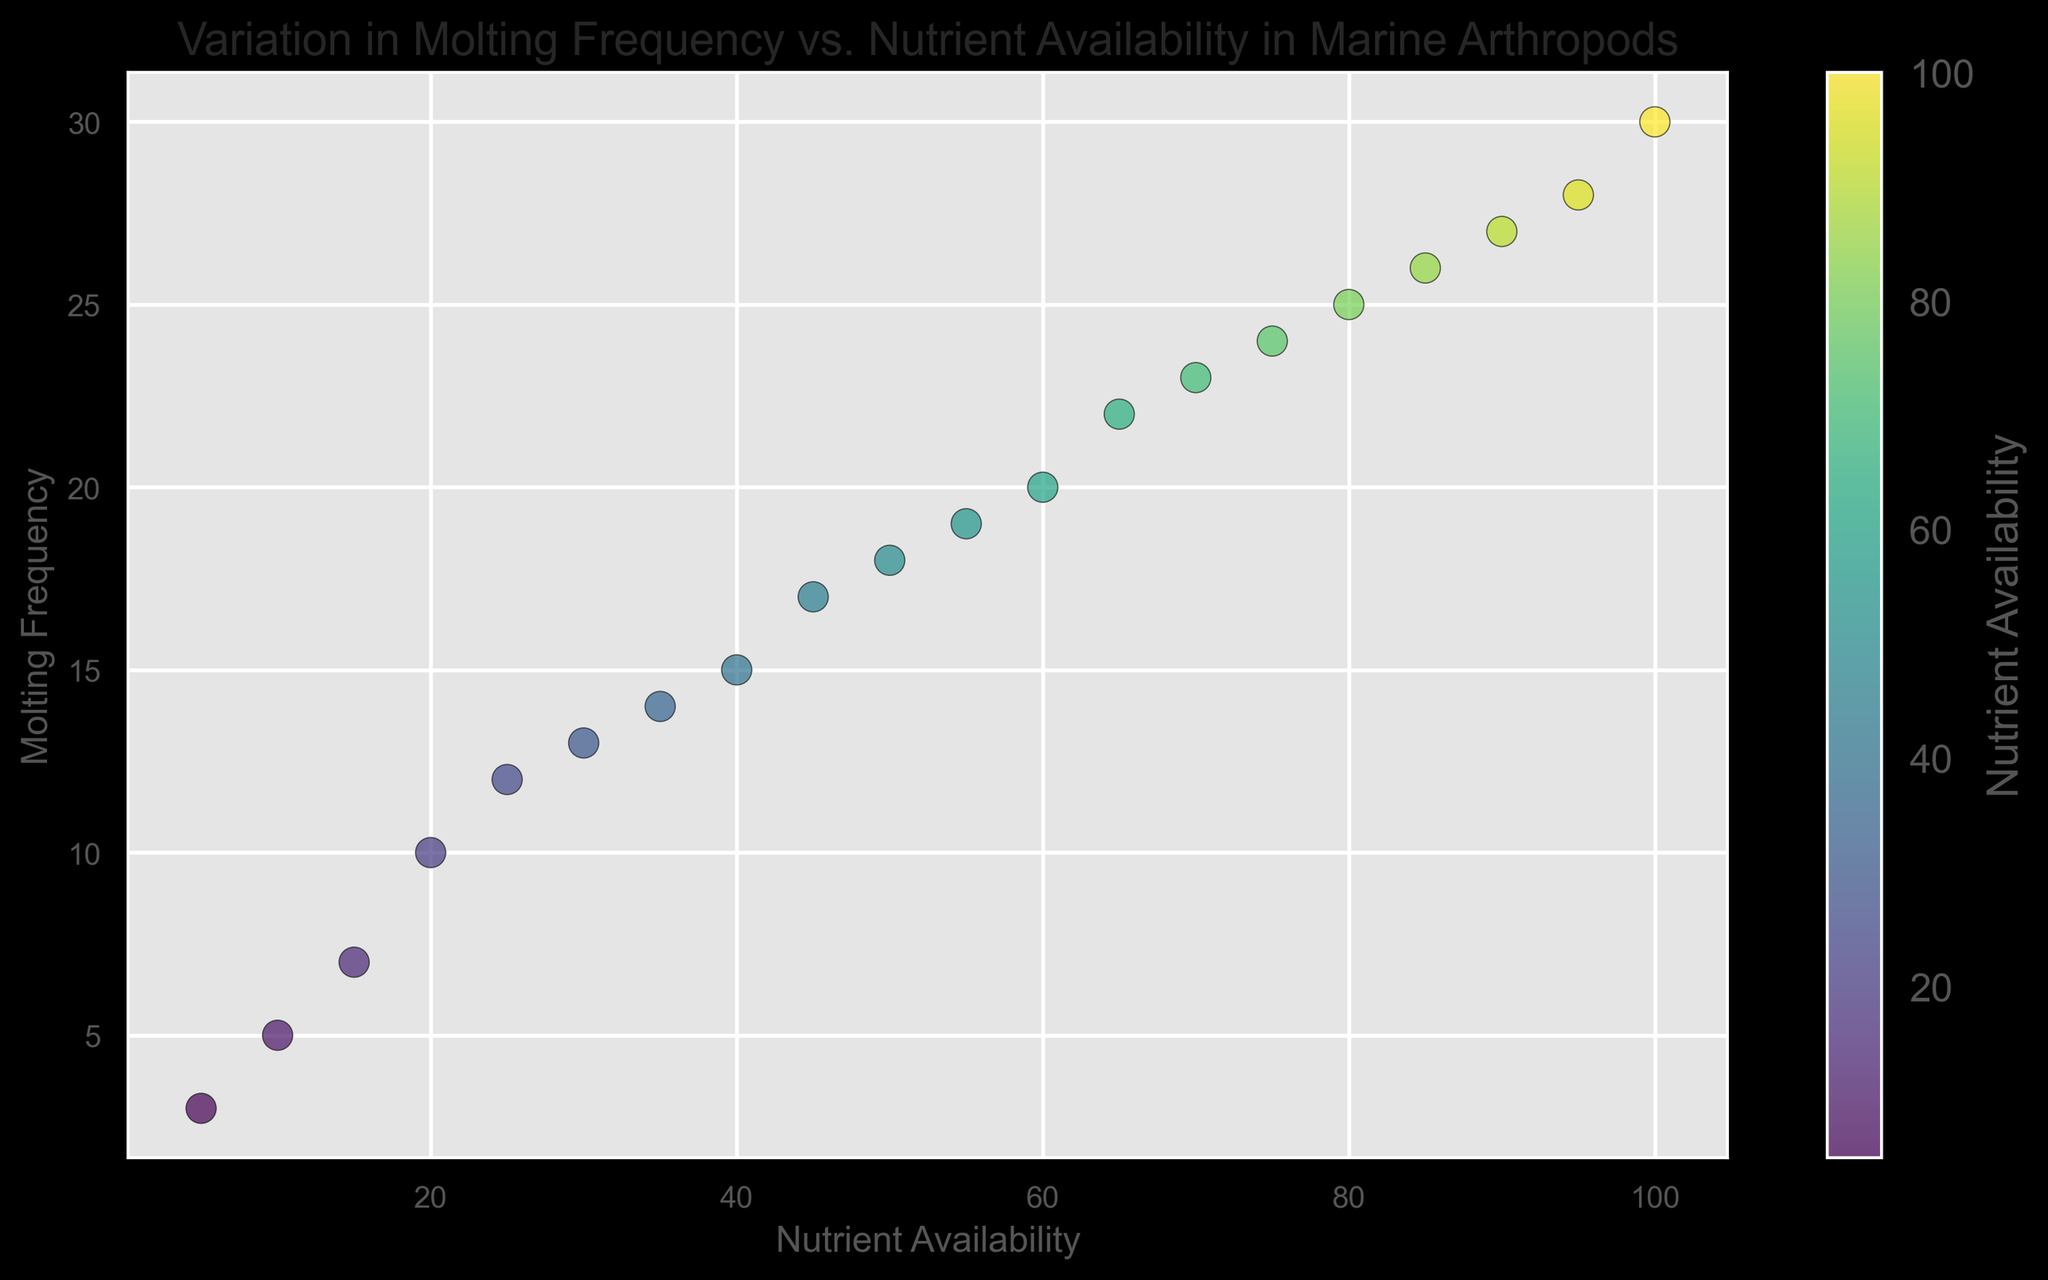What is the relationship between nutrient availability and molting frequency? From the scatter plot, it appears that as nutrient availability increases, the molting frequency of marine arthropods also increases, indicating a positive correlation.
Answer: Positive correlation Which data point has the highest molting frequency? The data point with the highest molting frequency is (100, 30) on the scatter plot.
Answer: (100, 30) How many data points have molting frequencies greater than 20? By observing the scatter plot, count the number of points above the molting frequency value of 20. There are 6 such points.
Answer: 6 Which is greater: the molting frequency at a nutrient availability of 30 or 70? Compare the values on the scatter plot for nutrient availabilities of 30 and 70. The molting frequencies are 13 (at 30) and 23 (at 70), so the molting frequency is greater at 70.
Answer: 23 What is the average molting frequency for nutrient availabilities of 25, 50, and 75? Find the molting frequencies for the given nutrient availabilities: 12 (at 25), 18 (at 50), and 24 (at 75). Sum them up: 12 + 18 + 24 = 54, then divide by 3 to get the average: 54 / 3 = 18.
Answer: 18 Which nutrient availability shows a molting frequency of 15? Locate the point on the scatter plot where the molting frequency is 15. This corresponds to a nutrient availability of 40.
Answer: 40 Between nutrient availabilities of 55 and 85, which shows a higher increase in molting frequency? Calculate the molting frequencies for both nutrient availabilities: 19 (at 55) and 26 (at 85). The increase is 26 - 19 = 7.
Answer: 7 What is the color of the data point with the highest molting frequency? Refer to the color bar and the specific data point (100, 30); based on the color gradient, the point should be dark green.
Answer: Dark green What is the nutrient availability that corresponds to the median molting frequency? First, find the median molting frequency, with 20 data points, the median is between the 10th and 11th values (sorted order): (18 + 19) / 2 = 18.5. Find the nutrient availabilities corresponding near this molting range.
Answer: Around 50 Which visual characteristic indicates nutrient availability on the scatter plot? The color of the points, which transitions from lighter to darker tones along the gradient as nutrient availability increases, indicates nutrient availability.
Answer: Color gradient 